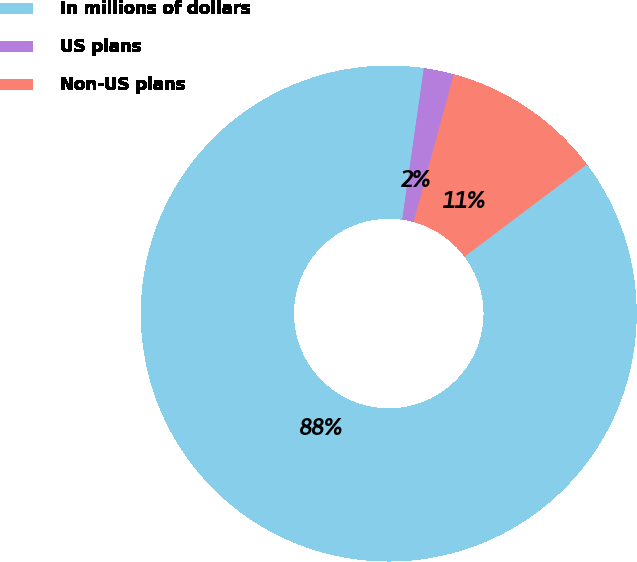<chart> <loc_0><loc_0><loc_500><loc_500><pie_chart><fcel>In millions of dollars<fcel>US plans<fcel>Non-US plans<nl><fcel>87.53%<fcel>1.96%<fcel>10.51%<nl></chart> 